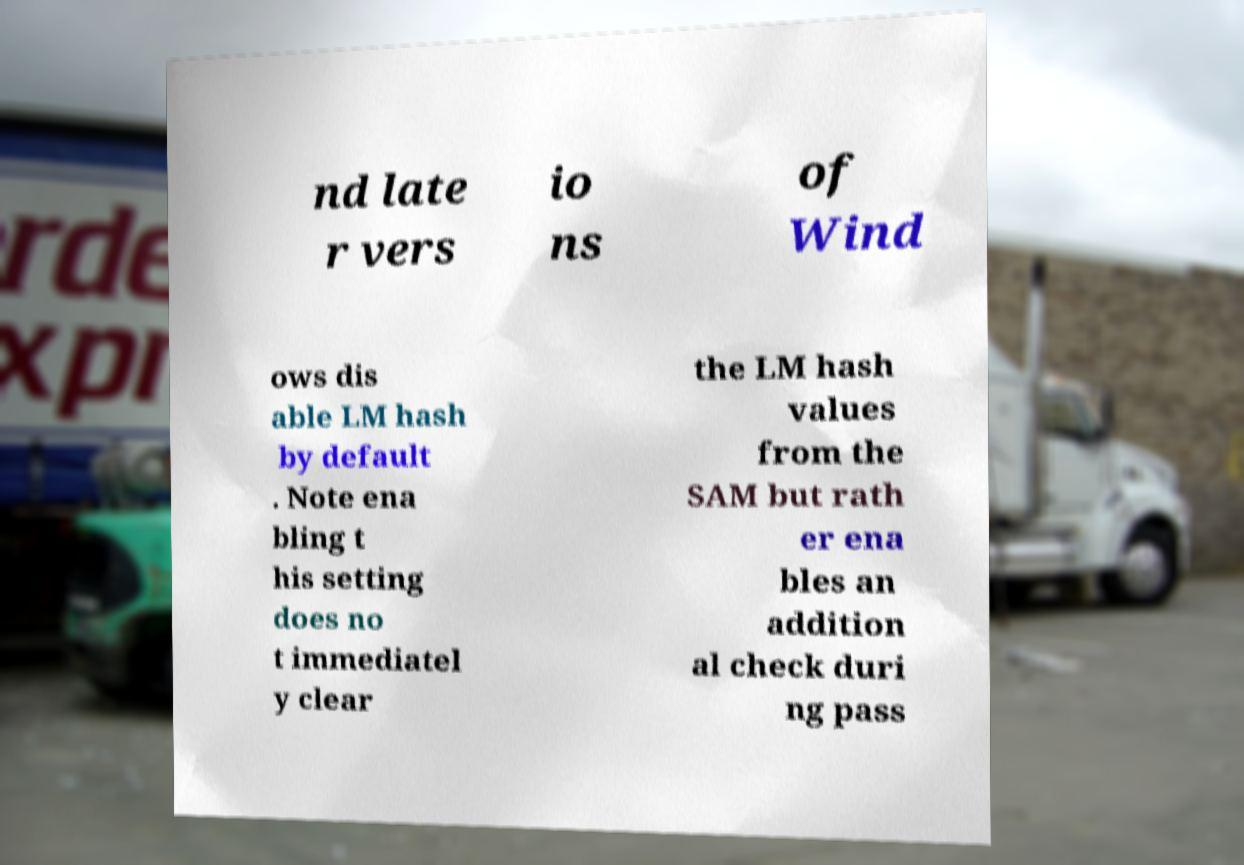What messages or text are displayed in this image? I need them in a readable, typed format. nd late r vers io ns of Wind ows dis able LM hash by default . Note ena bling t his setting does no t immediatel y clear the LM hash values from the SAM but rath er ena bles an addition al check duri ng pass 